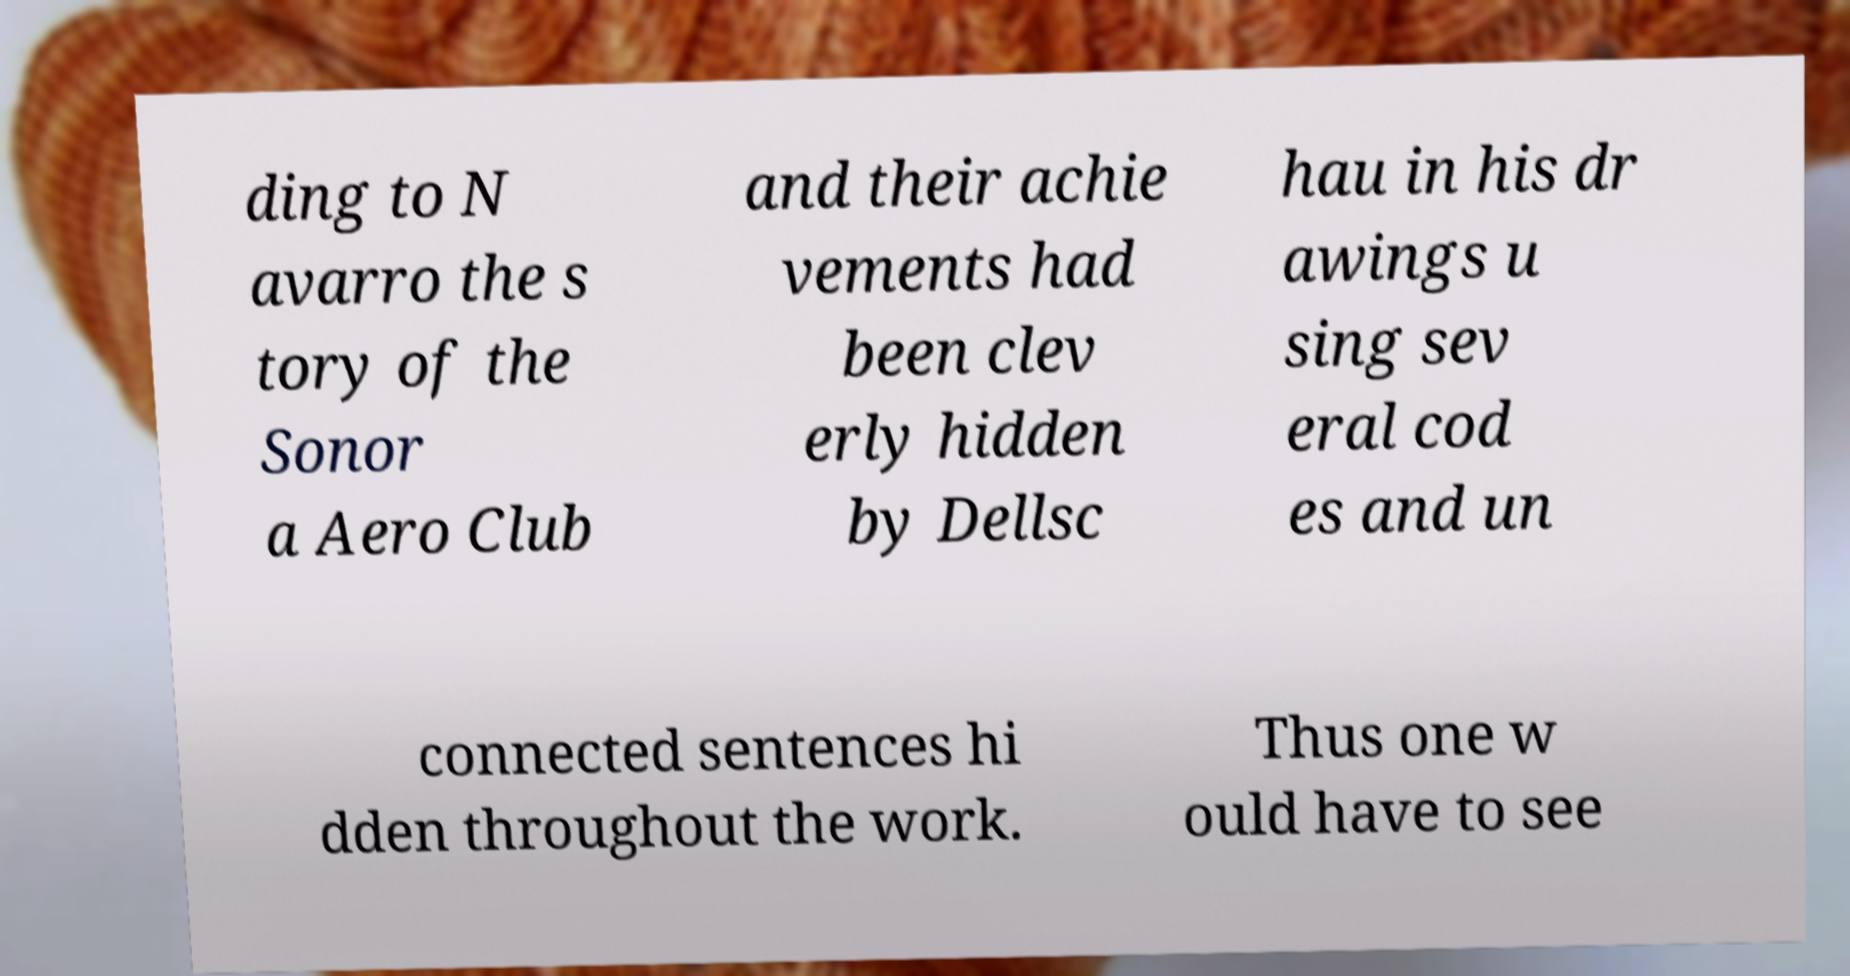Please read and relay the text visible in this image. What does it say? ding to N avarro the s tory of the Sonor a Aero Club and their achie vements had been clev erly hidden by Dellsc hau in his dr awings u sing sev eral cod es and un connected sentences hi dden throughout the work. Thus one w ould have to see 